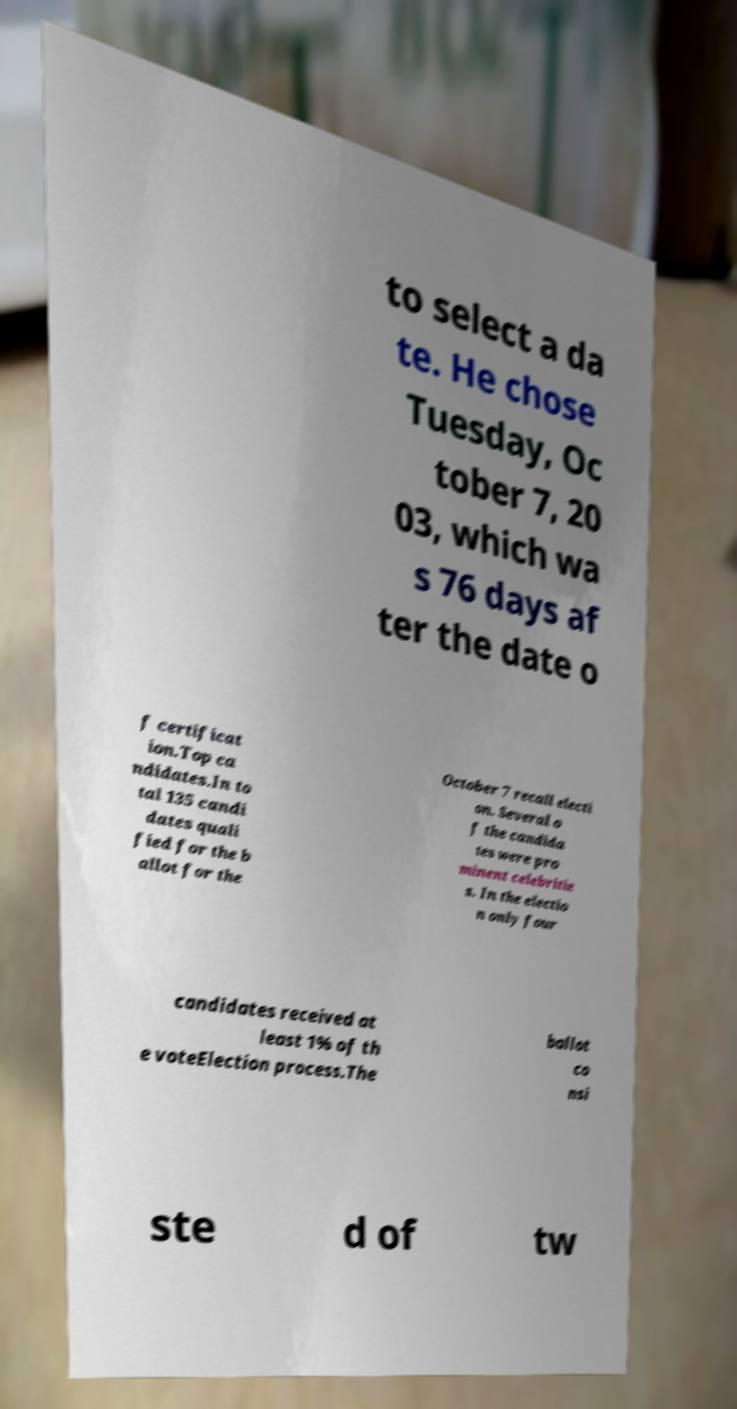There's text embedded in this image that I need extracted. Can you transcribe it verbatim? to select a da te. He chose Tuesday, Oc tober 7, 20 03, which wa s 76 days af ter the date o f certificat ion.Top ca ndidates.In to tal 135 candi dates quali fied for the b allot for the October 7 recall electi on. Several o f the candida tes were pro minent celebritie s. In the electio n only four candidates received at least 1% of th e voteElection process.The ballot co nsi ste d of tw 